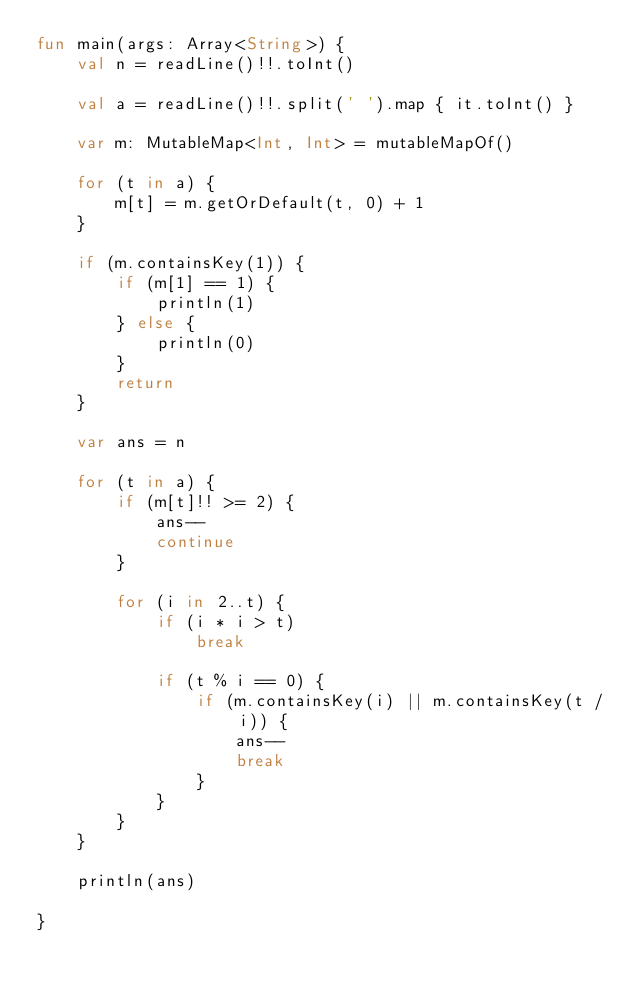Convert code to text. <code><loc_0><loc_0><loc_500><loc_500><_Kotlin_>fun main(args: Array<String>) {
    val n = readLine()!!.toInt()

    val a = readLine()!!.split(' ').map { it.toInt() }

    var m: MutableMap<Int, Int> = mutableMapOf()

    for (t in a) {
        m[t] = m.getOrDefault(t, 0) + 1
    }

    if (m.containsKey(1)) {
        if (m[1] == 1) {
            println(1)
        } else {
            println(0)
        }
        return
    }

    var ans = n

    for (t in a) {
        if (m[t]!! >= 2) {
            ans--
            continue
        }

        for (i in 2..t) {
            if (i * i > t)
                break

            if (t % i == 0) {
                if (m.containsKey(i) || m.containsKey(t / i)) {
                    ans--
                    break
                }
            }
        }
    }

    println(ans)

}</code> 